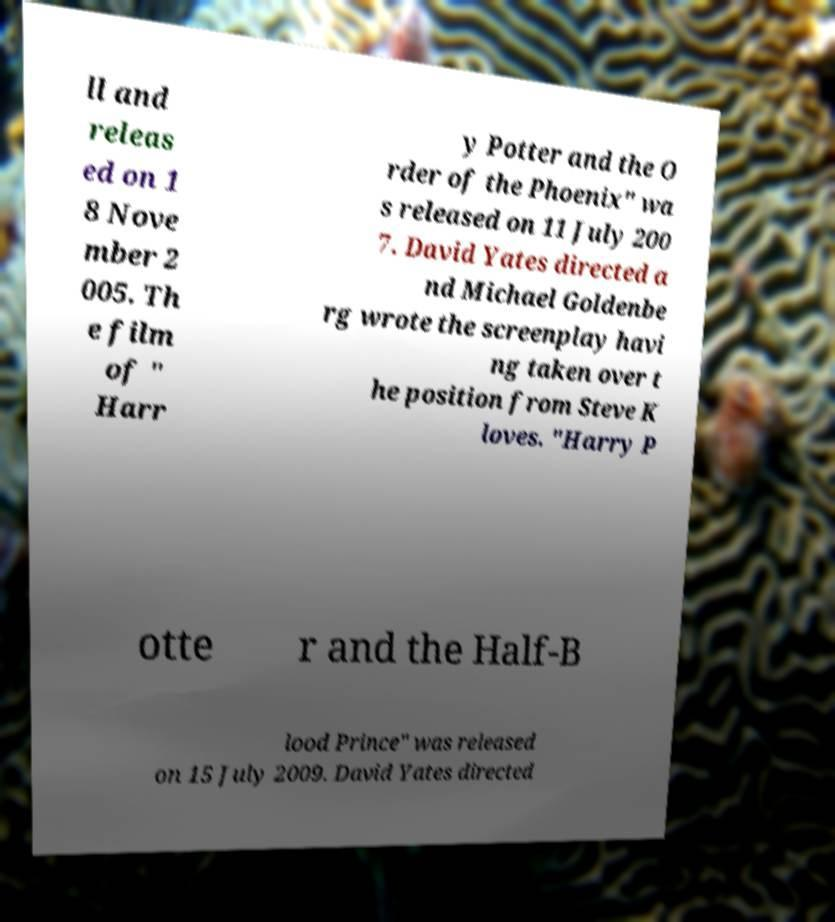Please identify and transcribe the text found in this image. ll and releas ed on 1 8 Nove mber 2 005. Th e film of " Harr y Potter and the O rder of the Phoenix" wa s released on 11 July 200 7. David Yates directed a nd Michael Goldenbe rg wrote the screenplay havi ng taken over t he position from Steve K loves. "Harry P otte r and the Half-B lood Prince" was released on 15 July 2009. David Yates directed 